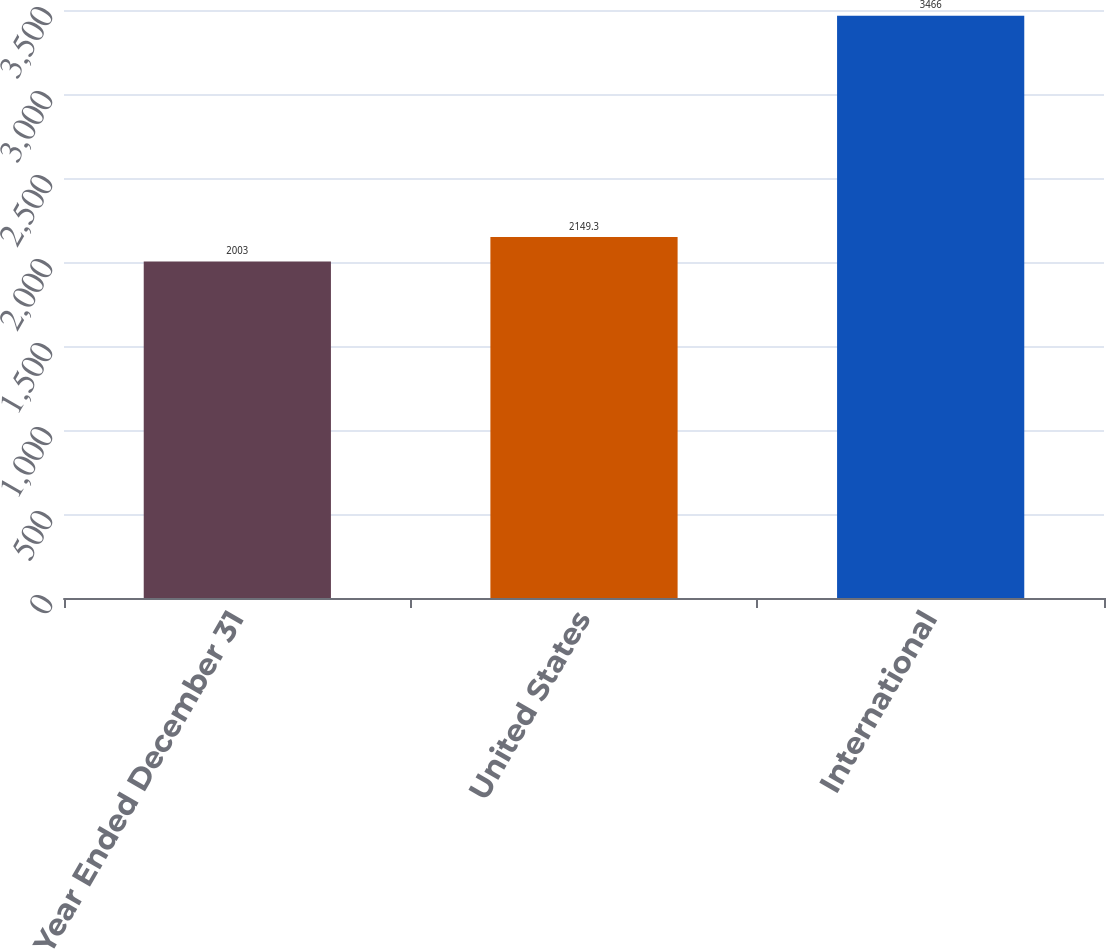Convert chart to OTSL. <chart><loc_0><loc_0><loc_500><loc_500><bar_chart><fcel>Year Ended December 31<fcel>United States<fcel>International<nl><fcel>2003<fcel>2149.3<fcel>3466<nl></chart> 